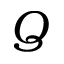Convert formula to latex. <formula><loc_0><loc_0><loc_500><loc_500>Q</formula> 